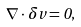<formula> <loc_0><loc_0><loc_500><loc_500>\nabla \cdot \delta v = 0 ,</formula> 